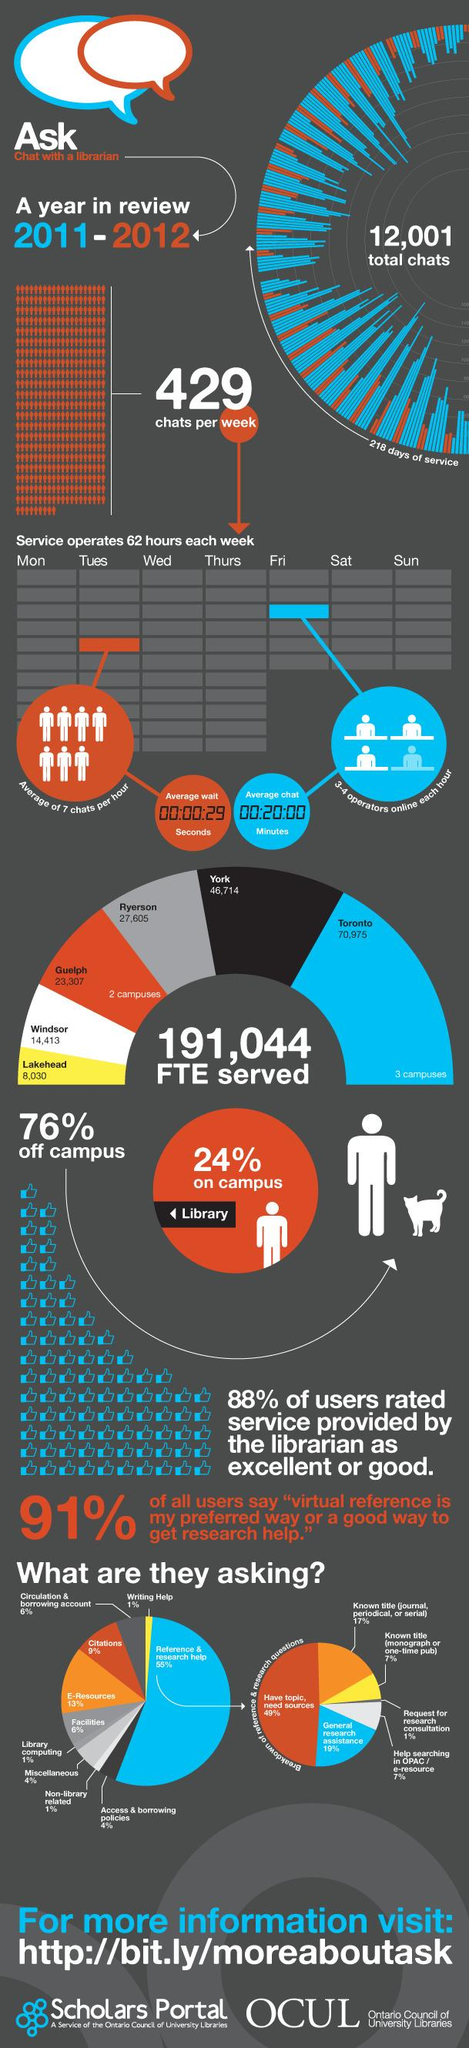Outline some significant characteristics in this image. In Toronto and Lakehead combined, a total of 79,005 Full-Time Equivalent (FTE) positions are served. The color blue represents the most frequently asked color, as compared to black and orange. In reference and research help, 17% represents the third most frequently asked question. The third most frequently asked question in reference and research help is related to the title of a specific journal, periodical, or serial. The second most frequently requested service by librarians is e-resources. 